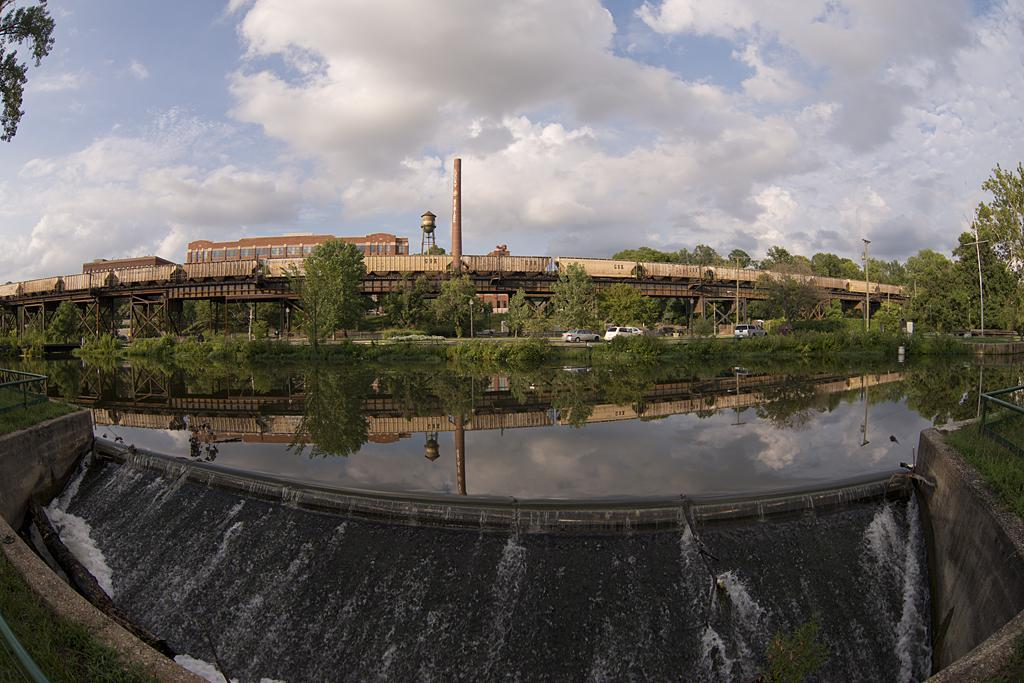What is the primary element present in the image? There is water in the image. What structures can be seen in the image? There are poles and a bridge in the image. What type of vegetation is present in the image? There are trees in the image. What can be seen behind the bridge? There are buildings visible behind the bridge. What part of the natural environment is visible in the image? The sky is visible in the image. Can you describe the condition of the shelf in the image? There is no shelf present in the image. How many kisses can be seen on the water in the image? There are no kisses visible in the image; it features water, poles, trees, a bridge, buildings, and the sky. 